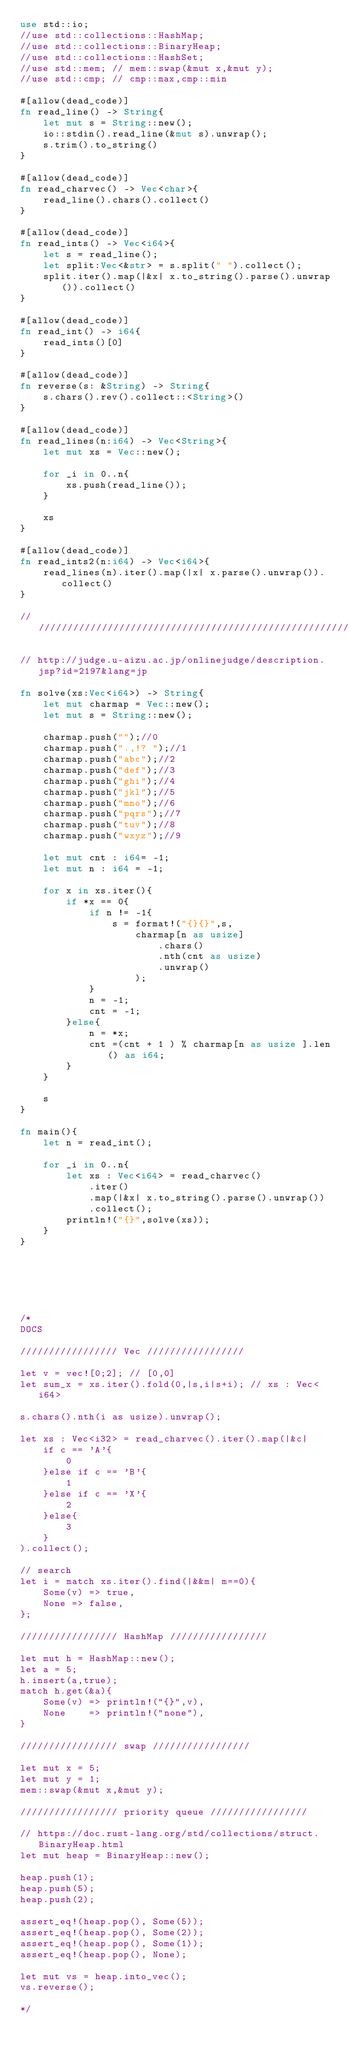<code> <loc_0><loc_0><loc_500><loc_500><_Rust_>use std::io;
//use std::collections::HashMap;
//use std::collections::BinaryHeap;
//use std::collections::HashSet;
//use std::mem; // mem::swap(&mut x,&mut y);
//use std::cmp; // cmp::max,cmp::min

#[allow(dead_code)]
fn read_line() -> String{
    let mut s = String::new();
    io::stdin().read_line(&mut s).unwrap();
    s.trim().to_string()
}

#[allow(dead_code)]
fn read_charvec() -> Vec<char>{
    read_line().chars().collect()
}

#[allow(dead_code)]
fn read_ints() -> Vec<i64>{
    let s = read_line();
    let split:Vec<&str> = s.split(" ").collect();
    split.iter().map(|&x| x.to_string().parse().unwrap()).collect()
}

#[allow(dead_code)]
fn read_int() -> i64{
    read_ints()[0]
}

#[allow(dead_code)]
fn reverse(s: &String) -> String{
    s.chars().rev().collect::<String>()
}

#[allow(dead_code)]
fn read_lines(n:i64) -> Vec<String>{
    let mut xs = Vec::new();

    for _i in 0..n{
        xs.push(read_line());
    }

    xs
}

#[allow(dead_code)]
fn read_ints2(n:i64) -> Vec<i64>{
    read_lines(n).iter().map(|x| x.parse().unwrap()).collect()
}

//////////////////////////////////////////////////////////////////////

// http://judge.u-aizu.ac.jp/onlinejudge/description.jsp?id=2197&lang=jp

fn solve(xs:Vec<i64>) -> String{
    let mut charmap = Vec::new();
    let mut s = String::new();

    charmap.push("");//0
    charmap.push(".,!? ");//1
    charmap.push("abc");//2
    charmap.push("def");//3
    charmap.push("ghi");//4
    charmap.push("jkl");//5
    charmap.push("mno");//6
    charmap.push("pqrs");//7
    charmap.push("tuv");//8
    charmap.push("wxyz");//9

    let mut cnt : i64= -1;
    let mut n : i64 = -1;

    for x in xs.iter(){
        if *x == 0{
            if n != -1{
                s = format!("{}{}",s,
                    charmap[n as usize]
                        .chars()
                        .nth(cnt as usize)
                        .unwrap()
                    );
            }
            n = -1;
            cnt = -1;
        }else{
            n = *x;
            cnt =(cnt + 1 ) % charmap[n as usize ].len() as i64;
        }
    }

    s
}

fn main(){
    let n = read_int();

    for _i in 0..n{
        let xs : Vec<i64> = read_charvec()
            .iter()
            .map(|&x| x.to_string().parse().unwrap())
            .collect();
        println!("{}",solve(xs));
    }
}






/*
DOCS

///////////////// Vec /////////////////

let v = vec![0;2]; // [0,0]
let sum_x = xs.iter().fold(0,|s,i|s+i); // xs : Vec<i64>

s.chars().nth(i as usize).unwrap();

let xs : Vec<i32> = read_charvec().iter().map(|&c| 
    if c == 'A'{
        0
    }else if c == 'B'{
        1
    }else if c == 'X'{
        2
    }else{
        3
    }
).collect();

// search
let i = match xs.iter().find(|&&m| m==0){
    Some(v) => true,
    None => false,
};

///////////////// HashMap /////////////////

let mut h = HashMap::new();
let a = 5;
h.insert(a,true);
match h.get(&a){
    Some(v) => println!("{}",v),
    None    => println!("none"),
}

///////////////// swap /////////////////

let mut x = 5;
let mut y = 1;
mem::swap(&mut x,&mut y);

///////////////// priority queue /////////////////

// https://doc.rust-lang.org/std/collections/struct.BinaryHeap.html
let mut heap = BinaryHeap::new();

heap.push(1);
heap.push(5);
heap.push(2);

assert_eq!(heap.pop(), Some(5));
assert_eq!(heap.pop(), Some(2));
assert_eq!(heap.pop(), Some(1));
assert_eq!(heap.pop(), None);

let mut vs = heap.into_vec();
vs.reverse();

*/

</code> 